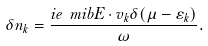Convert formula to latex. <formula><loc_0><loc_0><loc_500><loc_500>\delta n _ { k } = \frac { i e \ m i b { E \cdot v } _ { k } \delta ( \mu - \varepsilon _ { k } ) } { \omega } .</formula> 